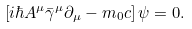Convert formula to latex. <formula><loc_0><loc_0><loc_500><loc_500>\left [ i \hbar { A } ^ { \mu } \bar { \gamma } ^ { \mu } \partial _ { \mu } - m _ { 0 } c \right ] \psi = 0 .</formula> 